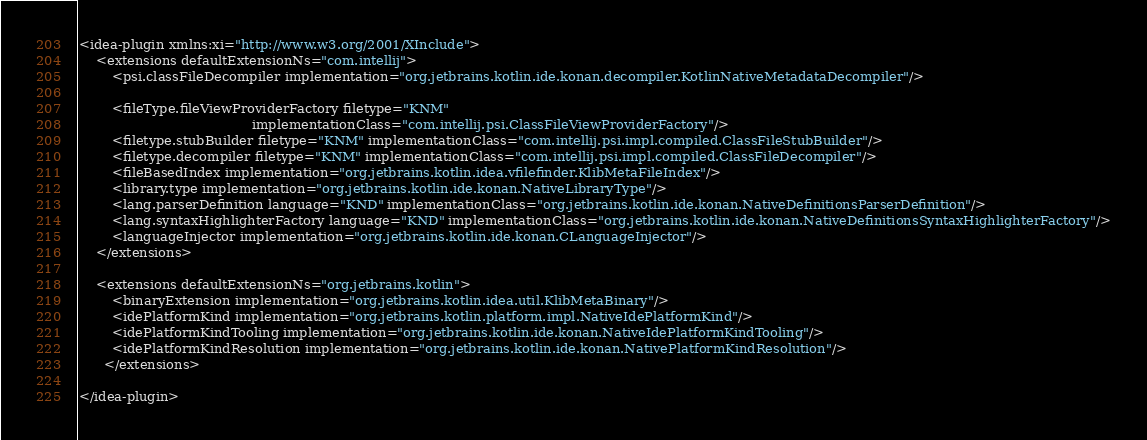Convert code to text. <code><loc_0><loc_0><loc_500><loc_500><_XML_><idea-plugin xmlns:xi="http://www.w3.org/2001/XInclude">
    <extensions defaultExtensionNs="com.intellij">
        <psi.classFileDecompiler implementation="org.jetbrains.kotlin.ide.konan.decompiler.KotlinNativeMetadataDecompiler"/>

        <fileType.fileViewProviderFactory filetype="KNM"
                                          implementationClass="com.intellij.psi.ClassFileViewProviderFactory"/>
        <filetype.stubBuilder filetype="KNM" implementationClass="com.intellij.psi.impl.compiled.ClassFileStubBuilder"/>
        <filetype.decompiler filetype="KNM" implementationClass="com.intellij.psi.impl.compiled.ClassFileDecompiler"/>
        <fileBasedIndex implementation="org.jetbrains.kotlin.idea.vfilefinder.KlibMetaFileIndex"/>
        <library.type implementation="org.jetbrains.kotlin.ide.konan.NativeLibraryType"/>
        <lang.parserDefinition language="KND" implementationClass="org.jetbrains.kotlin.ide.konan.NativeDefinitionsParserDefinition"/>
        <lang.syntaxHighlighterFactory language="KND" implementationClass="org.jetbrains.kotlin.ide.konan.NativeDefinitionsSyntaxHighlighterFactory"/>
        <languageInjector implementation="org.jetbrains.kotlin.ide.konan.CLanguageInjector"/>
    </extensions>

    <extensions defaultExtensionNs="org.jetbrains.kotlin">
        <binaryExtension implementation="org.jetbrains.kotlin.idea.util.KlibMetaBinary"/>
        <idePlatformKind implementation="org.jetbrains.kotlin.platform.impl.NativeIdePlatformKind"/>
        <idePlatformKindTooling implementation="org.jetbrains.kotlin.ide.konan.NativeIdePlatformKindTooling"/>
        <idePlatformKindResolution implementation="org.jetbrains.kotlin.ide.konan.NativePlatformKindResolution"/>
      </extensions>

</idea-plugin>
</code> 